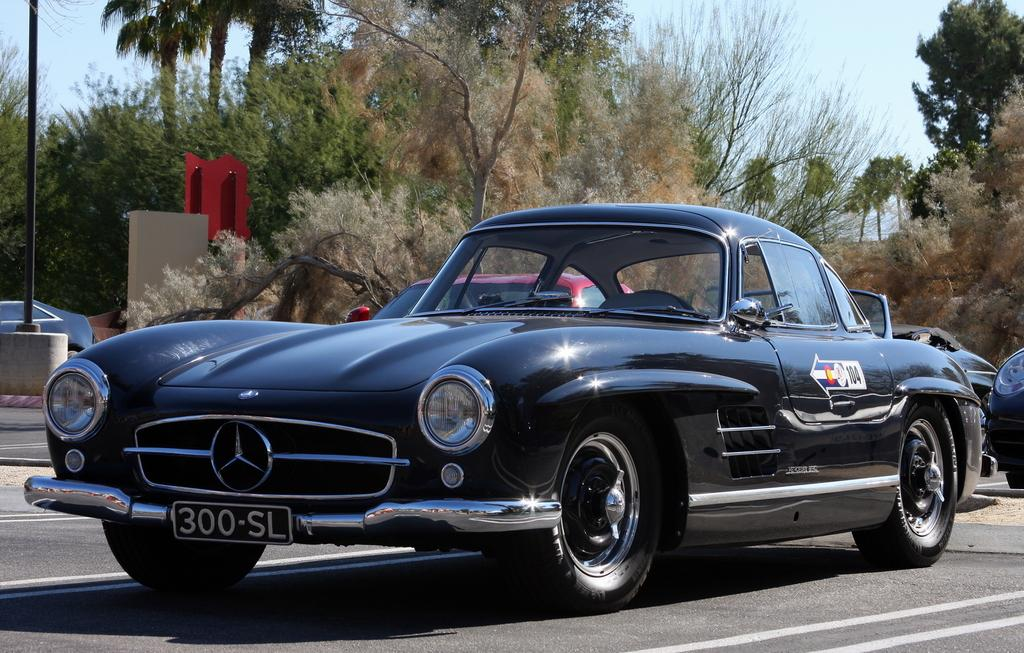What can be seen on the road in the image? There are vehicles on the road in the image. What is located behind the vehicles? There is a pole and a red board behind the vehicles. What type of vegetation is visible in the image? There are trees visible in the image. What is visible above the vehicles and trees? The sky is visible in the image. How many cats are sitting on the red board in the image? There are no cats present in the image; the red board is behind the vehicles. What type of art can be seen on the vehicles in the image? There is no specific art mentioned or visible on the vehicles in the image. 